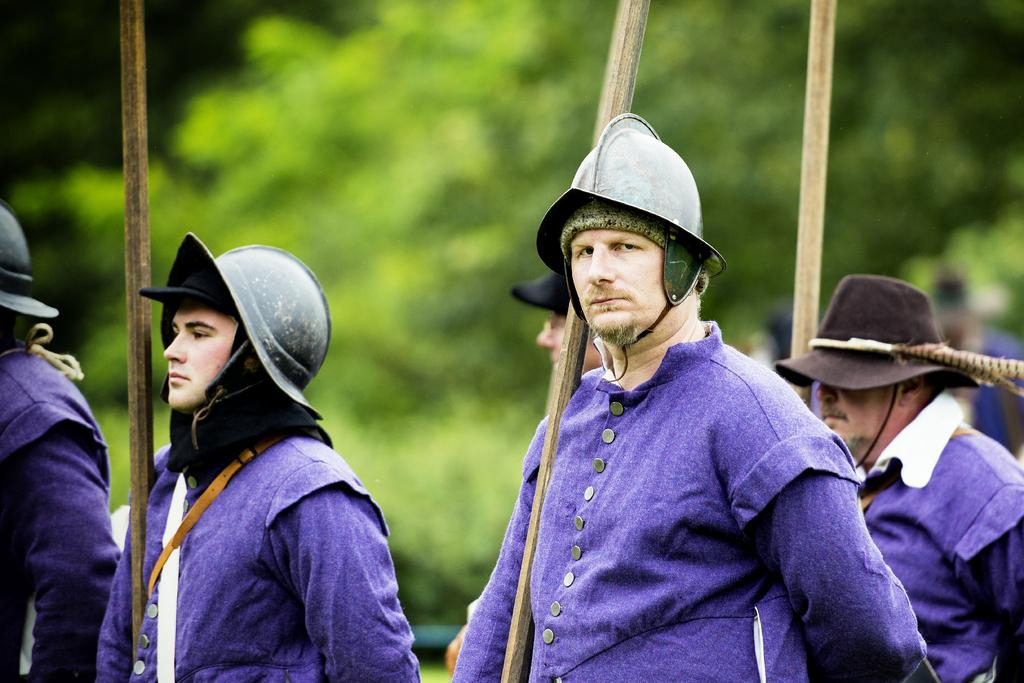What can be seen in the foreground of the image? There are people in the foreground of the image. What are the people wearing on their heads? The people are wearing helmets. What are the people holding in their hands? The people are holding wooden sticks. What type of natural environment is visible in the background of the image? There are trees in the background of the image. What type of scent can be detected from the wooden sticks in the image? There is no indication of a scent in the image, and the wooden sticks do not have a scent mentioned in the facts. 